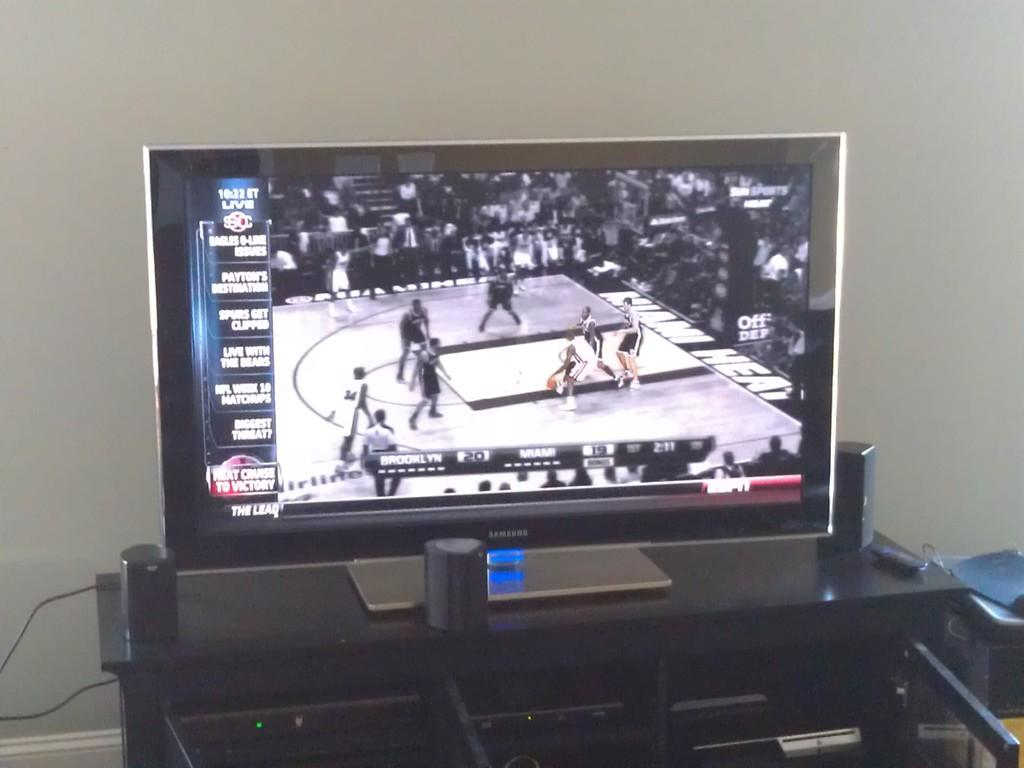<image>
Describe the image concisely. A flat screen TV is made by the Samsung corporation. 